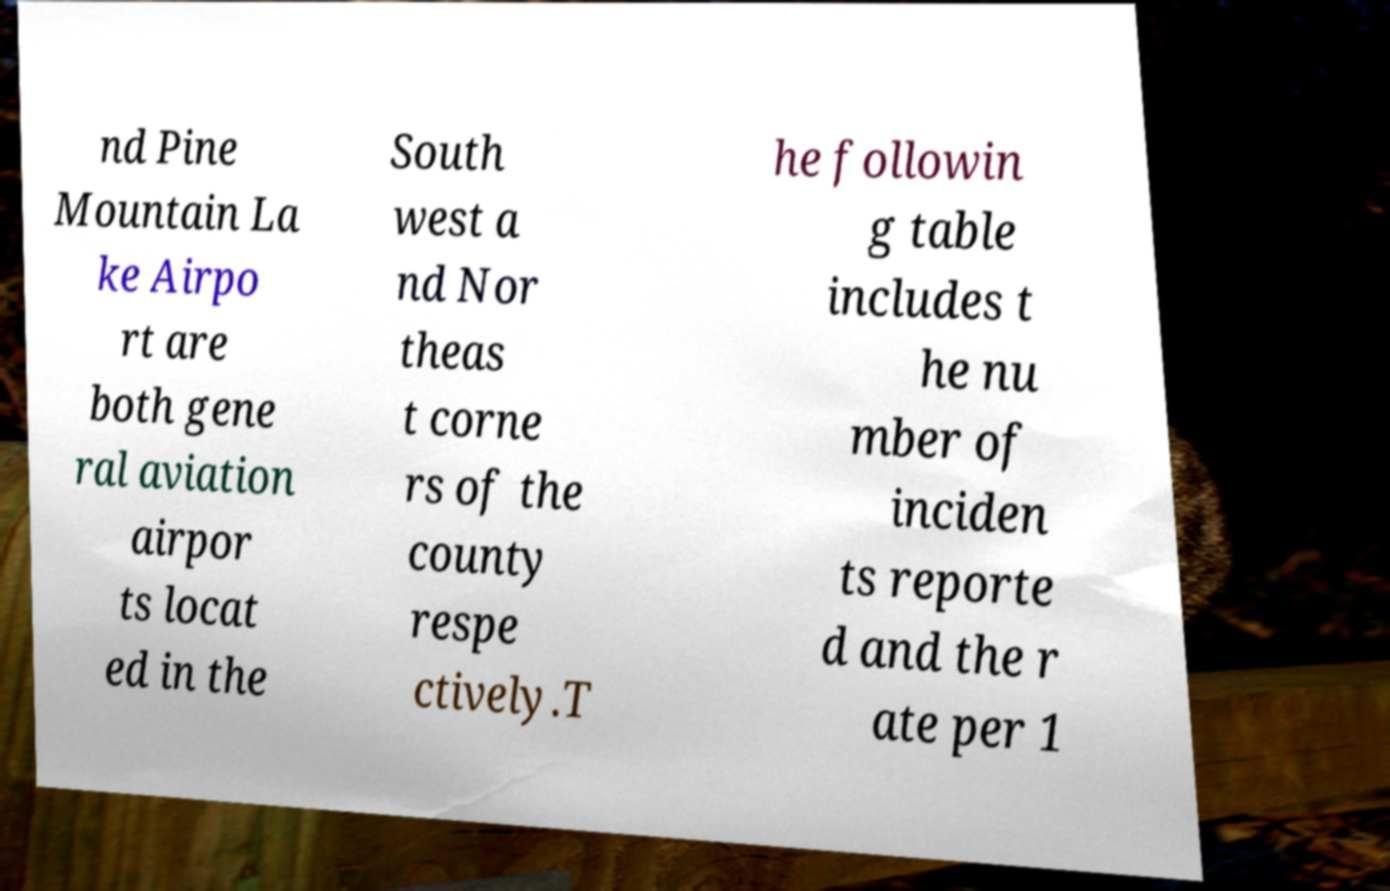Can you accurately transcribe the text from the provided image for me? nd Pine Mountain La ke Airpo rt are both gene ral aviation airpor ts locat ed in the South west a nd Nor theas t corne rs of the county respe ctively.T he followin g table includes t he nu mber of inciden ts reporte d and the r ate per 1 